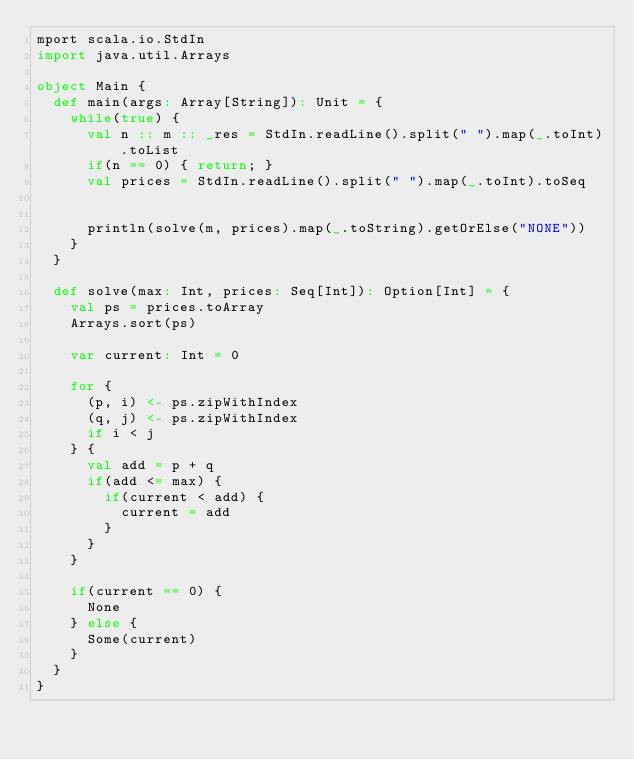<code> <loc_0><loc_0><loc_500><loc_500><_Scala_>mport scala.io.StdIn
import java.util.Arrays
 
object Main {
  def main(args: Array[String]): Unit = {
    while(true) {
      val n :: m :: _res = StdIn.readLine().split(" ").map(_.toInt).toList
      if(n == 0) { return; }
      val prices = StdIn.readLine().split(" ").map(_.toInt).toSeq
 
 
      println(solve(m, prices).map(_.toString).getOrElse("NONE"))
    }
  }
 
  def solve(max: Int, prices: Seq[Int]): Option[Int] = {
    val ps = prices.toArray
    Arrays.sort(ps)
 
    var current: Int = 0
 
    for {
      (p, i) <- ps.zipWithIndex
      (q, j) <- ps.zipWithIndex
      if i < j
    } {
      val add = p + q
      if(add <= max) {
        if(current < add) {
          current = add
        }
      }
    }
 
    if(current == 0) {
      None
    } else {
      Some(current)
    }
  }
}
</code> 